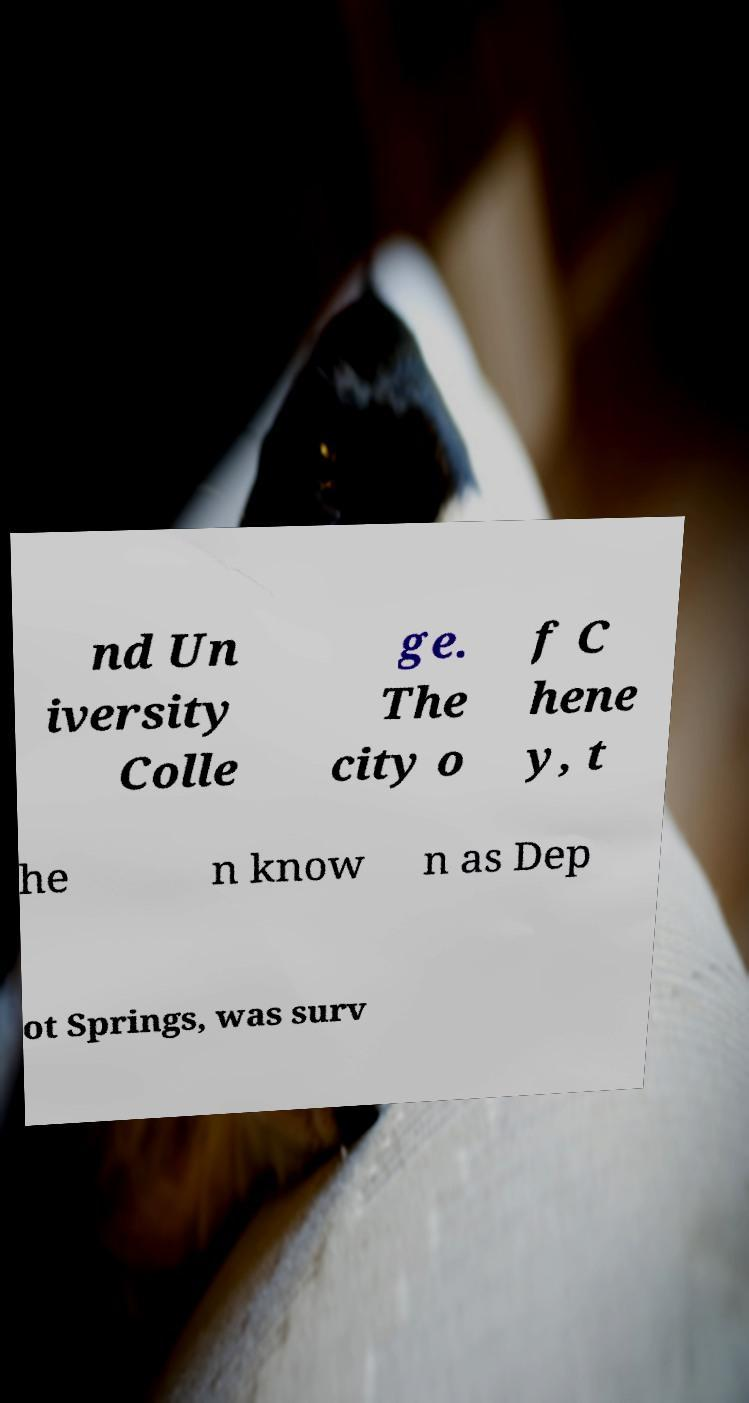For documentation purposes, I need the text within this image transcribed. Could you provide that? nd Un iversity Colle ge. The city o f C hene y, t he n know n as Dep ot Springs, was surv 